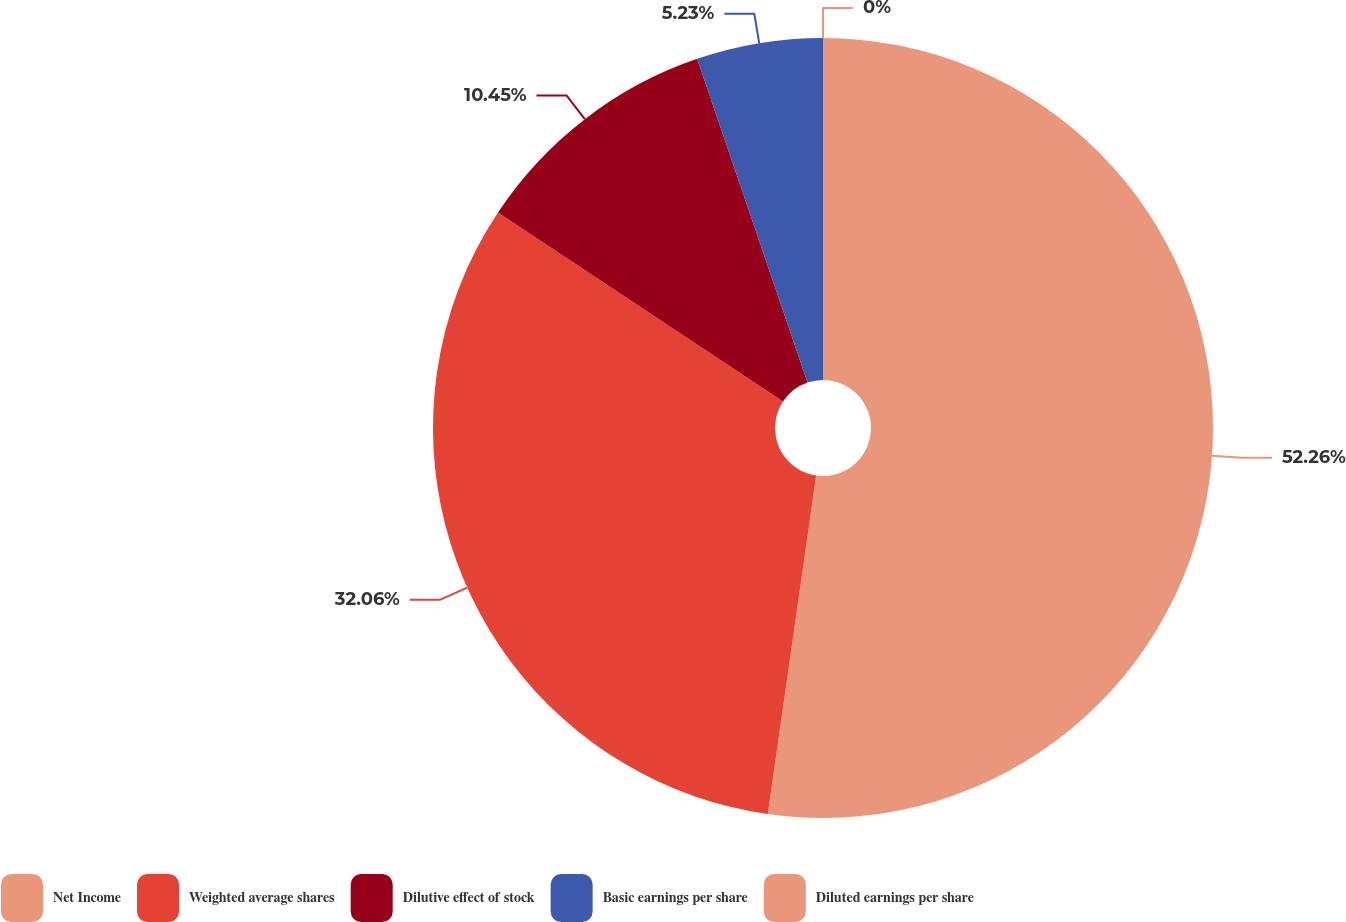Convert chart to OTSL. <chart><loc_0><loc_0><loc_500><loc_500><pie_chart><fcel>Net Income<fcel>Weighted average shares<fcel>Dilutive effect of stock<fcel>Basic earnings per share<fcel>Diluted earnings per share<nl><fcel>52.26%<fcel>32.06%<fcel>10.45%<fcel>5.23%<fcel>0.0%<nl></chart> 